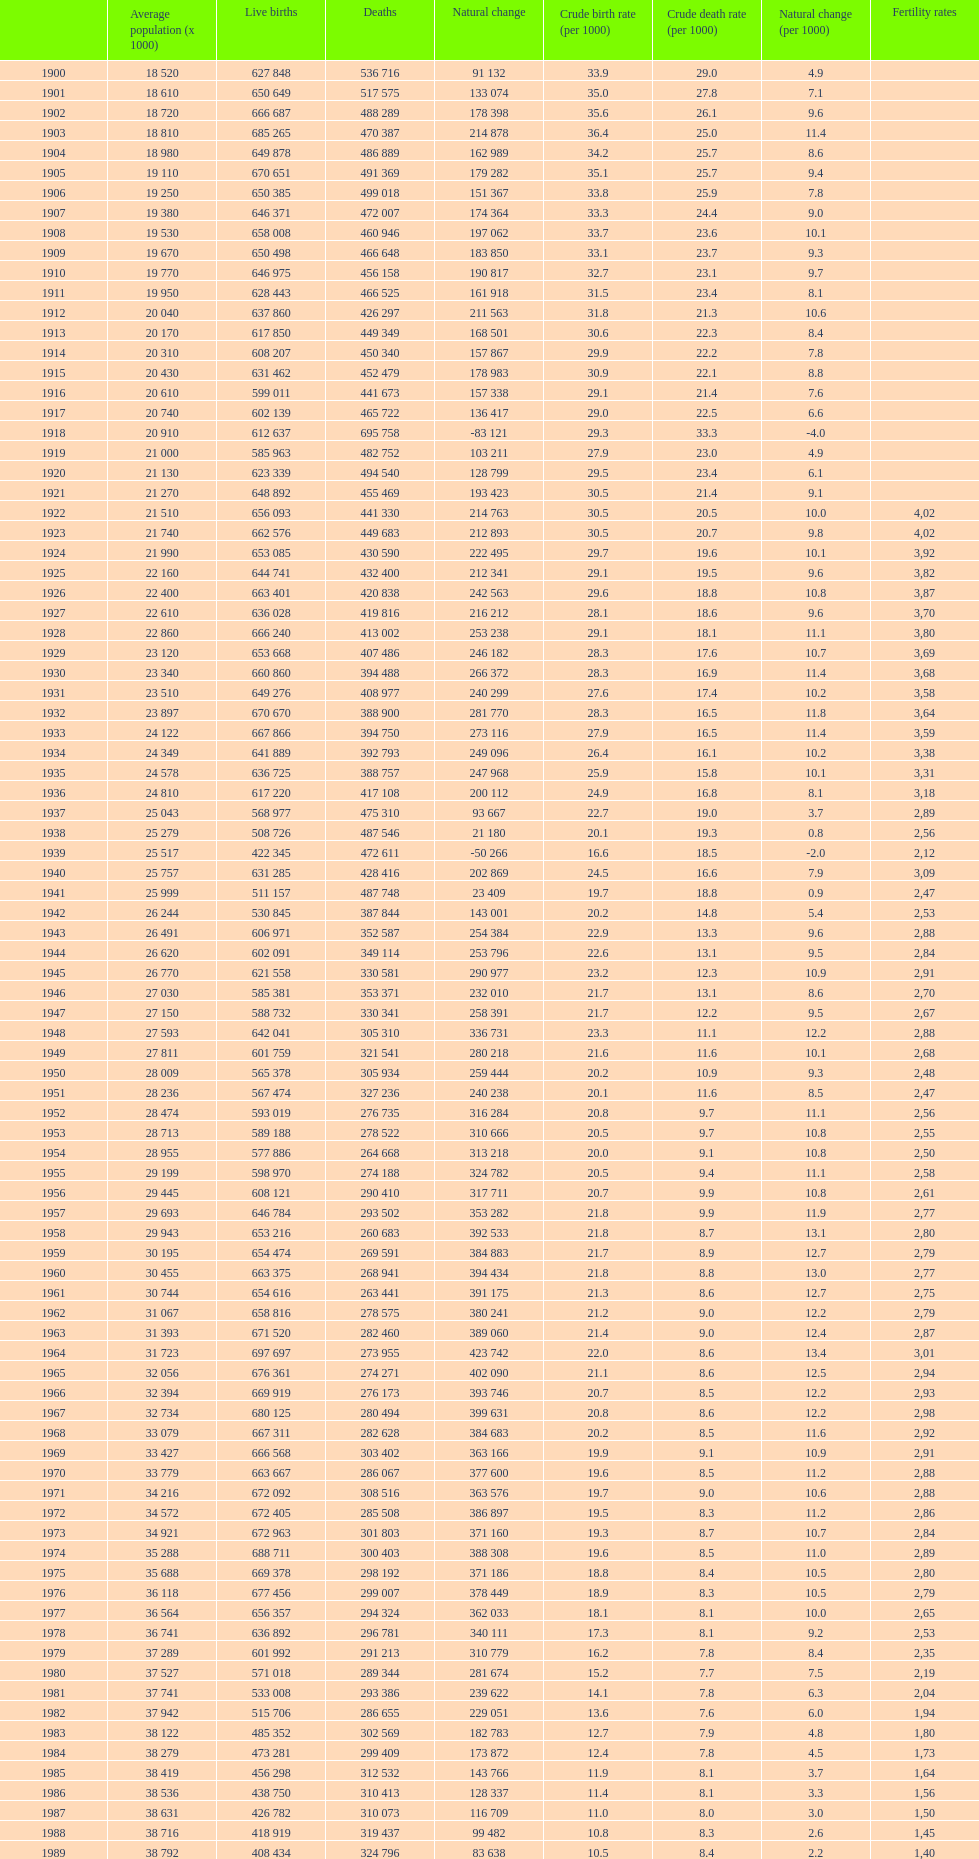What year features a crude birth rate of 2 1928. 